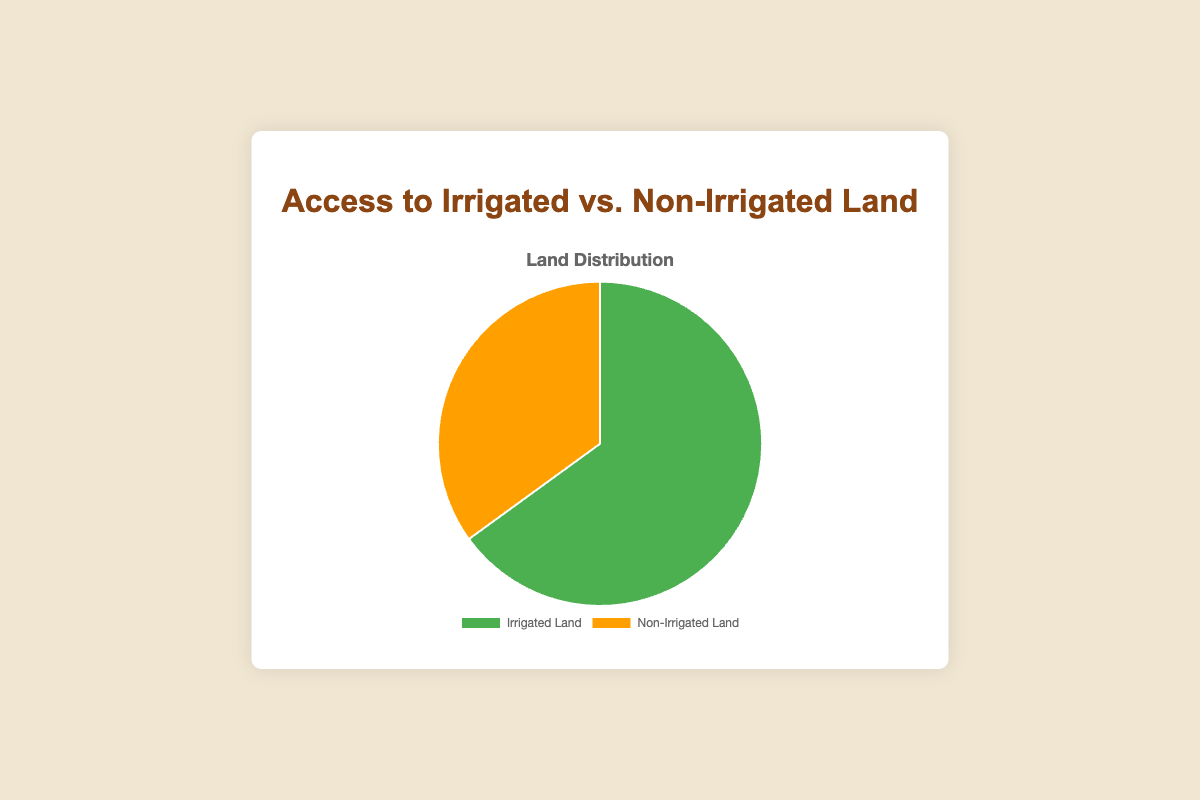what percentage of land is irrigated? The pie chart lists the percentage of irrigated vs. non-irrigated land. The segment labeled "Irrigated Land" is marked with 65%, indicating the irrigated portion of the land.
Answer: 65% What percentage of land is non-irrigated? The pie chart displays labels for both irrigated and non-irrigated land, with the "Non-Irrigated Land" segment showing 35%.
Answer: 35% How does the percentage of irrigated land compare to non-irrigated land? By looking at the pie chart, the "Irrigated Land" portion is 65% and the "Non-Irrigated Land" portion is 35%. 65% is almost double 35%, and therefore, irrigated land is significantly greater in percentage than non-irrigated land.
Answer: Irrigated land is nearly double the non-irrigated land What is the difference in percentage between irrigated and non-irrigated land? To find the difference, subtract the non-irrigated land percentage (35%) from the irrigated land percentage (65%): 65% - 35% = 30%.
Answer: 30% If the total land area is 100 hectares, how many hectares are non-irrigated? Given that 35% of the total land is non-irrigated, calculate 35% of 100 hectares by multiplying: 100 * 0.35 = 35 hectares.
Answer: 35 hectares What color is used to represent the irrigated land? The pie chart uses different colors to differentiate between categories. The segment for "Irrigated Land" is displayed in green.
Answer: Green What color is used to represent the non-irrigated land? The pie chart uses different colors to differentiate between categories. The segment for "Non-Irrigated Land" is displayed in an orange shade.
Answer: Orange If we convert the percentages into ratios, what is the ratio of irrigated land to non-irrigated land? The ratio of irrigated to non-irrigated land is determined by their percentage values: 65% (irrigated) to 35% (non-irrigated). Simplify this ratio: 65/35 = 13/7. So, the ratio is 13:7.
Answer: 13:7 